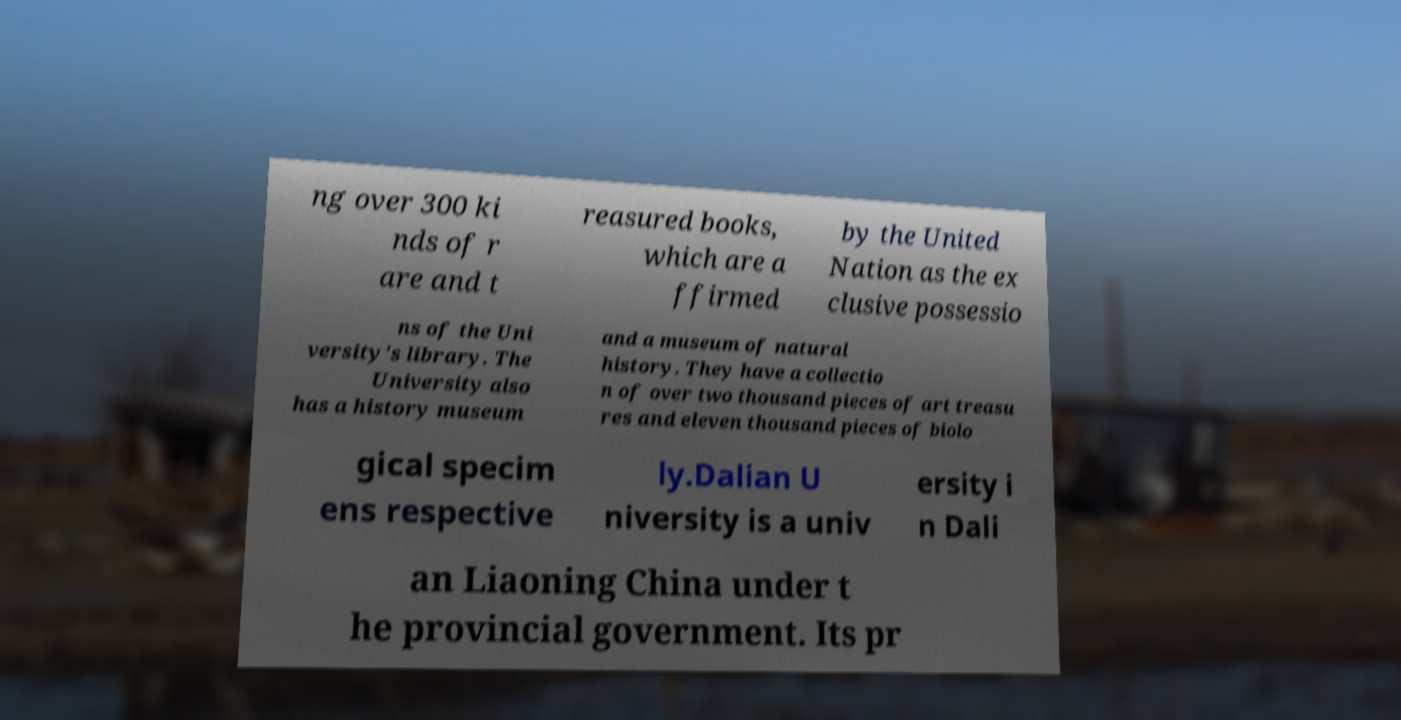What messages or text are displayed in this image? I need them in a readable, typed format. ng over 300 ki nds of r are and t reasured books, which are a ffirmed by the United Nation as the ex clusive possessio ns of the Uni versity's library. The University also has a history museum and a museum of natural history. They have a collectio n of over two thousand pieces of art treasu res and eleven thousand pieces of biolo gical specim ens respective ly.Dalian U niversity is a univ ersity i n Dali an Liaoning China under t he provincial government. Its pr 